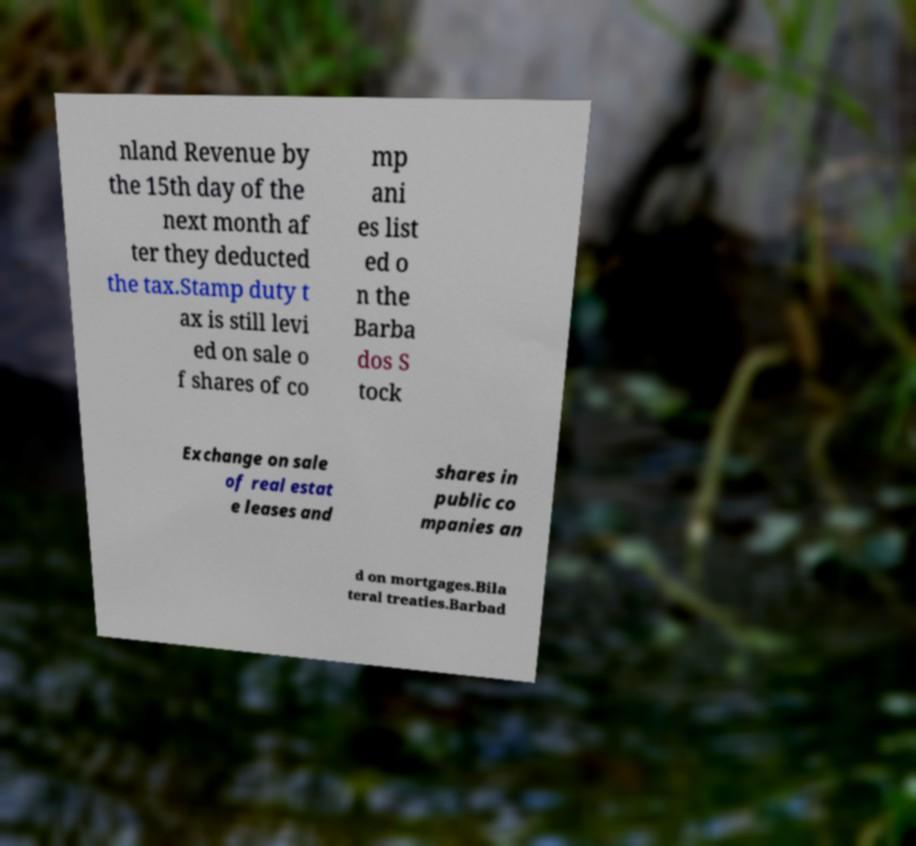There's text embedded in this image that I need extracted. Can you transcribe it verbatim? nland Revenue by the 15th day of the next month af ter they deducted the tax.Stamp duty t ax is still levi ed on sale o f shares of co mp ani es list ed o n the Barba dos S tock Exchange on sale of real estat e leases and shares in public co mpanies an d on mortgages.Bila teral treaties.Barbad 